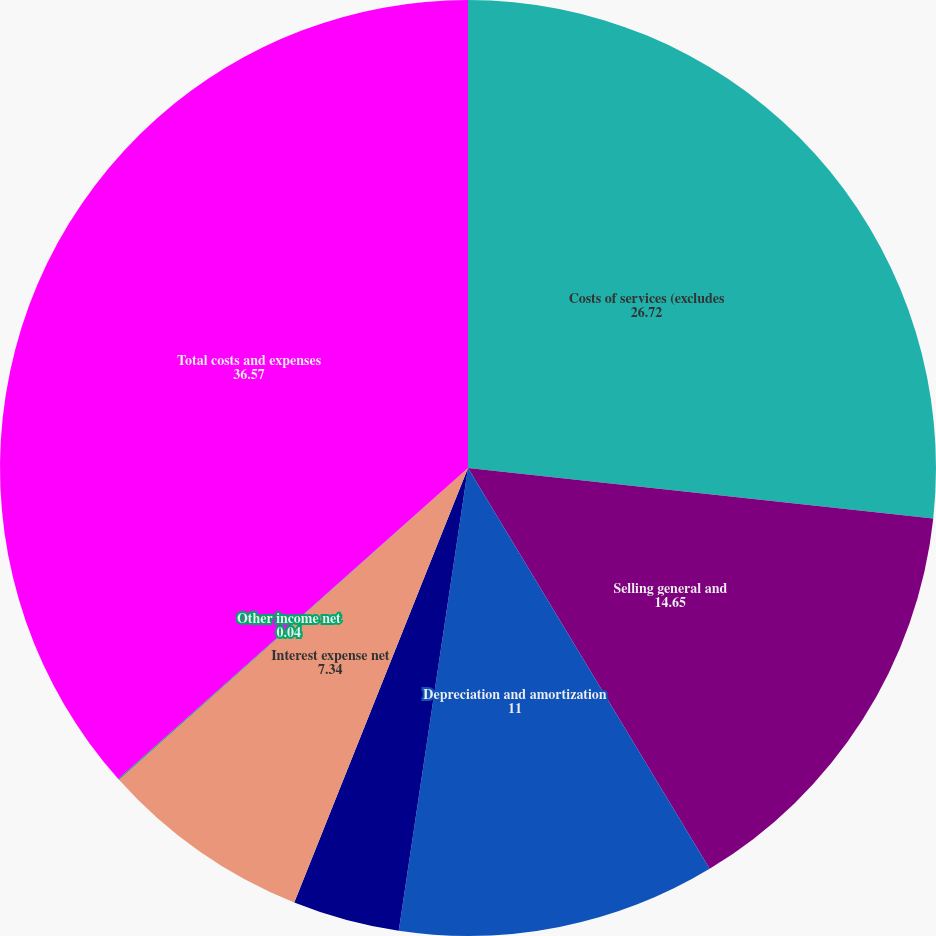Convert chart to OTSL. <chart><loc_0><loc_0><loc_500><loc_500><pie_chart><fcel>Costs of services (excludes<fcel>Selling general and<fcel>Depreciation and amortization<fcel>Restructuring costs<fcel>Interest expense net<fcel>Other income net<fcel>Total costs and expenses<nl><fcel>26.72%<fcel>14.65%<fcel>11.0%<fcel>3.69%<fcel>7.34%<fcel>0.04%<fcel>36.57%<nl></chart> 